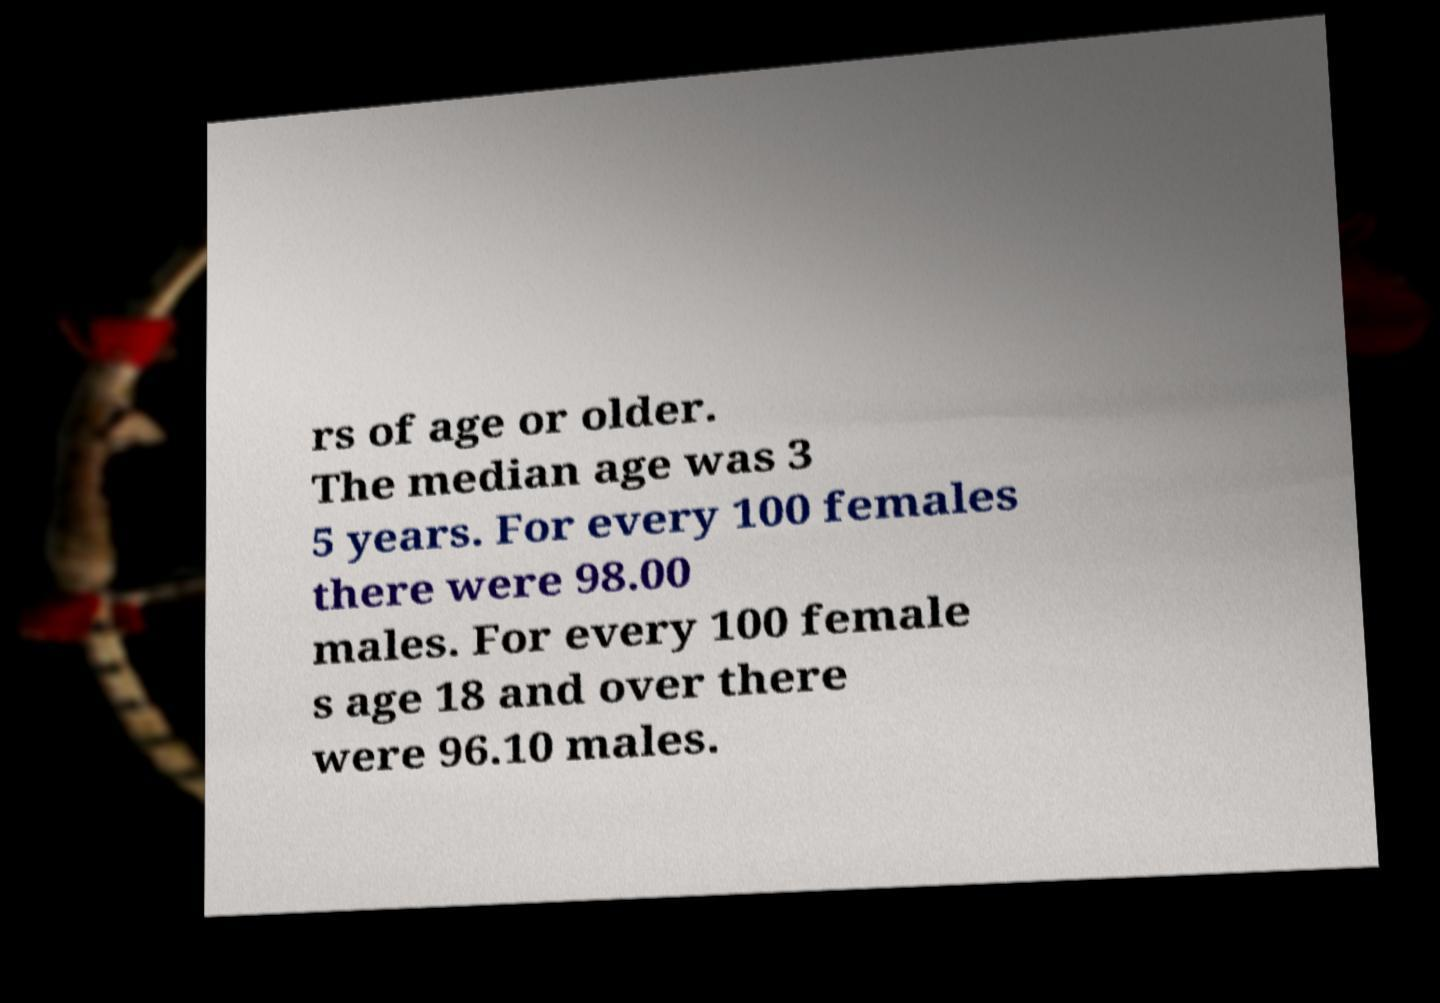Can you accurately transcribe the text from the provided image for me? rs of age or older. The median age was 3 5 years. For every 100 females there were 98.00 males. For every 100 female s age 18 and over there were 96.10 males. 